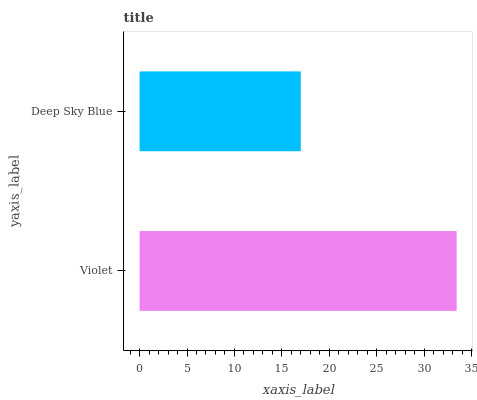Is Deep Sky Blue the minimum?
Answer yes or no. Yes. Is Violet the maximum?
Answer yes or no. Yes. Is Deep Sky Blue the maximum?
Answer yes or no. No. Is Violet greater than Deep Sky Blue?
Answer yes or no. Yes. Is Deep Sky Blue less than Violet?
Answer yes or no. Yes. Is Deep Sky Blue greater than Violet?
Answer yes or no. No. Is Violet less than Deep Sky Blue?
Answer yes or no. No. Is Violet the high median?
Answer yes or no. Yes. Is Deep Sky Blue the low median?
Answer yes or no. Yes. Is Deep Sky Blue the high median?
Answer yes or no. No. Is Violet the low median?
Answer yes or no. No. 